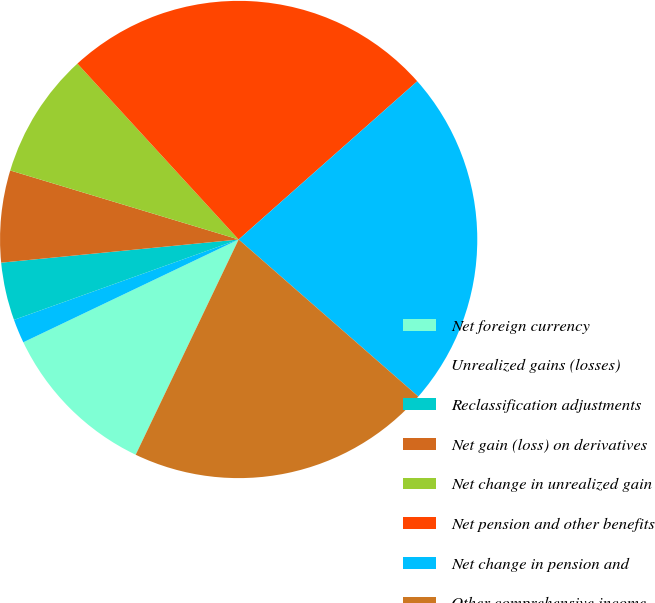Convert chart. <chart><loc_0><loc_0><loc_500><loc_500><pie_chart><fcel>Net foreign currency<fcel>Unrealized gains (losses)<fcel>Reclassification adjustments<fcel>Net gain (loss) on derivatives<fcel>Net change in unrealized gain<fcel>Net pension and other benefits<fcel>Net change in pension and<fcel>Other comprehensive income<nl><fcel>10.81%<fcel>1.62%<fcel>3.92%<fcel>6.22%<fcel>8.52%<fcel>25.27%<fcel>22.97%<fcel>20.67%<nl></chart> 